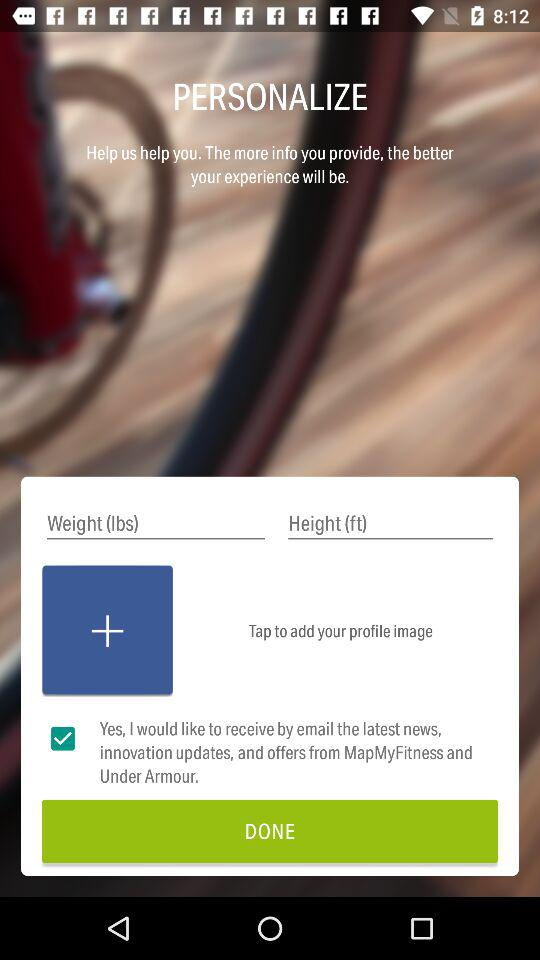What is the current status of "Yes, I would like to receive by email the latest news, innovation updates, and offers from MapMyFitness and Under Armour"? The status is "on". 